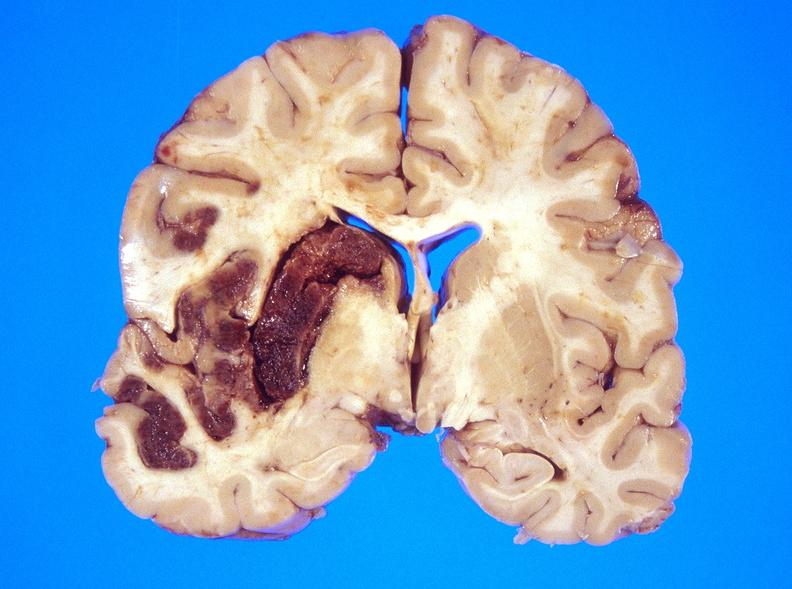what does this image show?
Answer the question using a single word or phrase. Hemorrhagic reperfusion infarct 